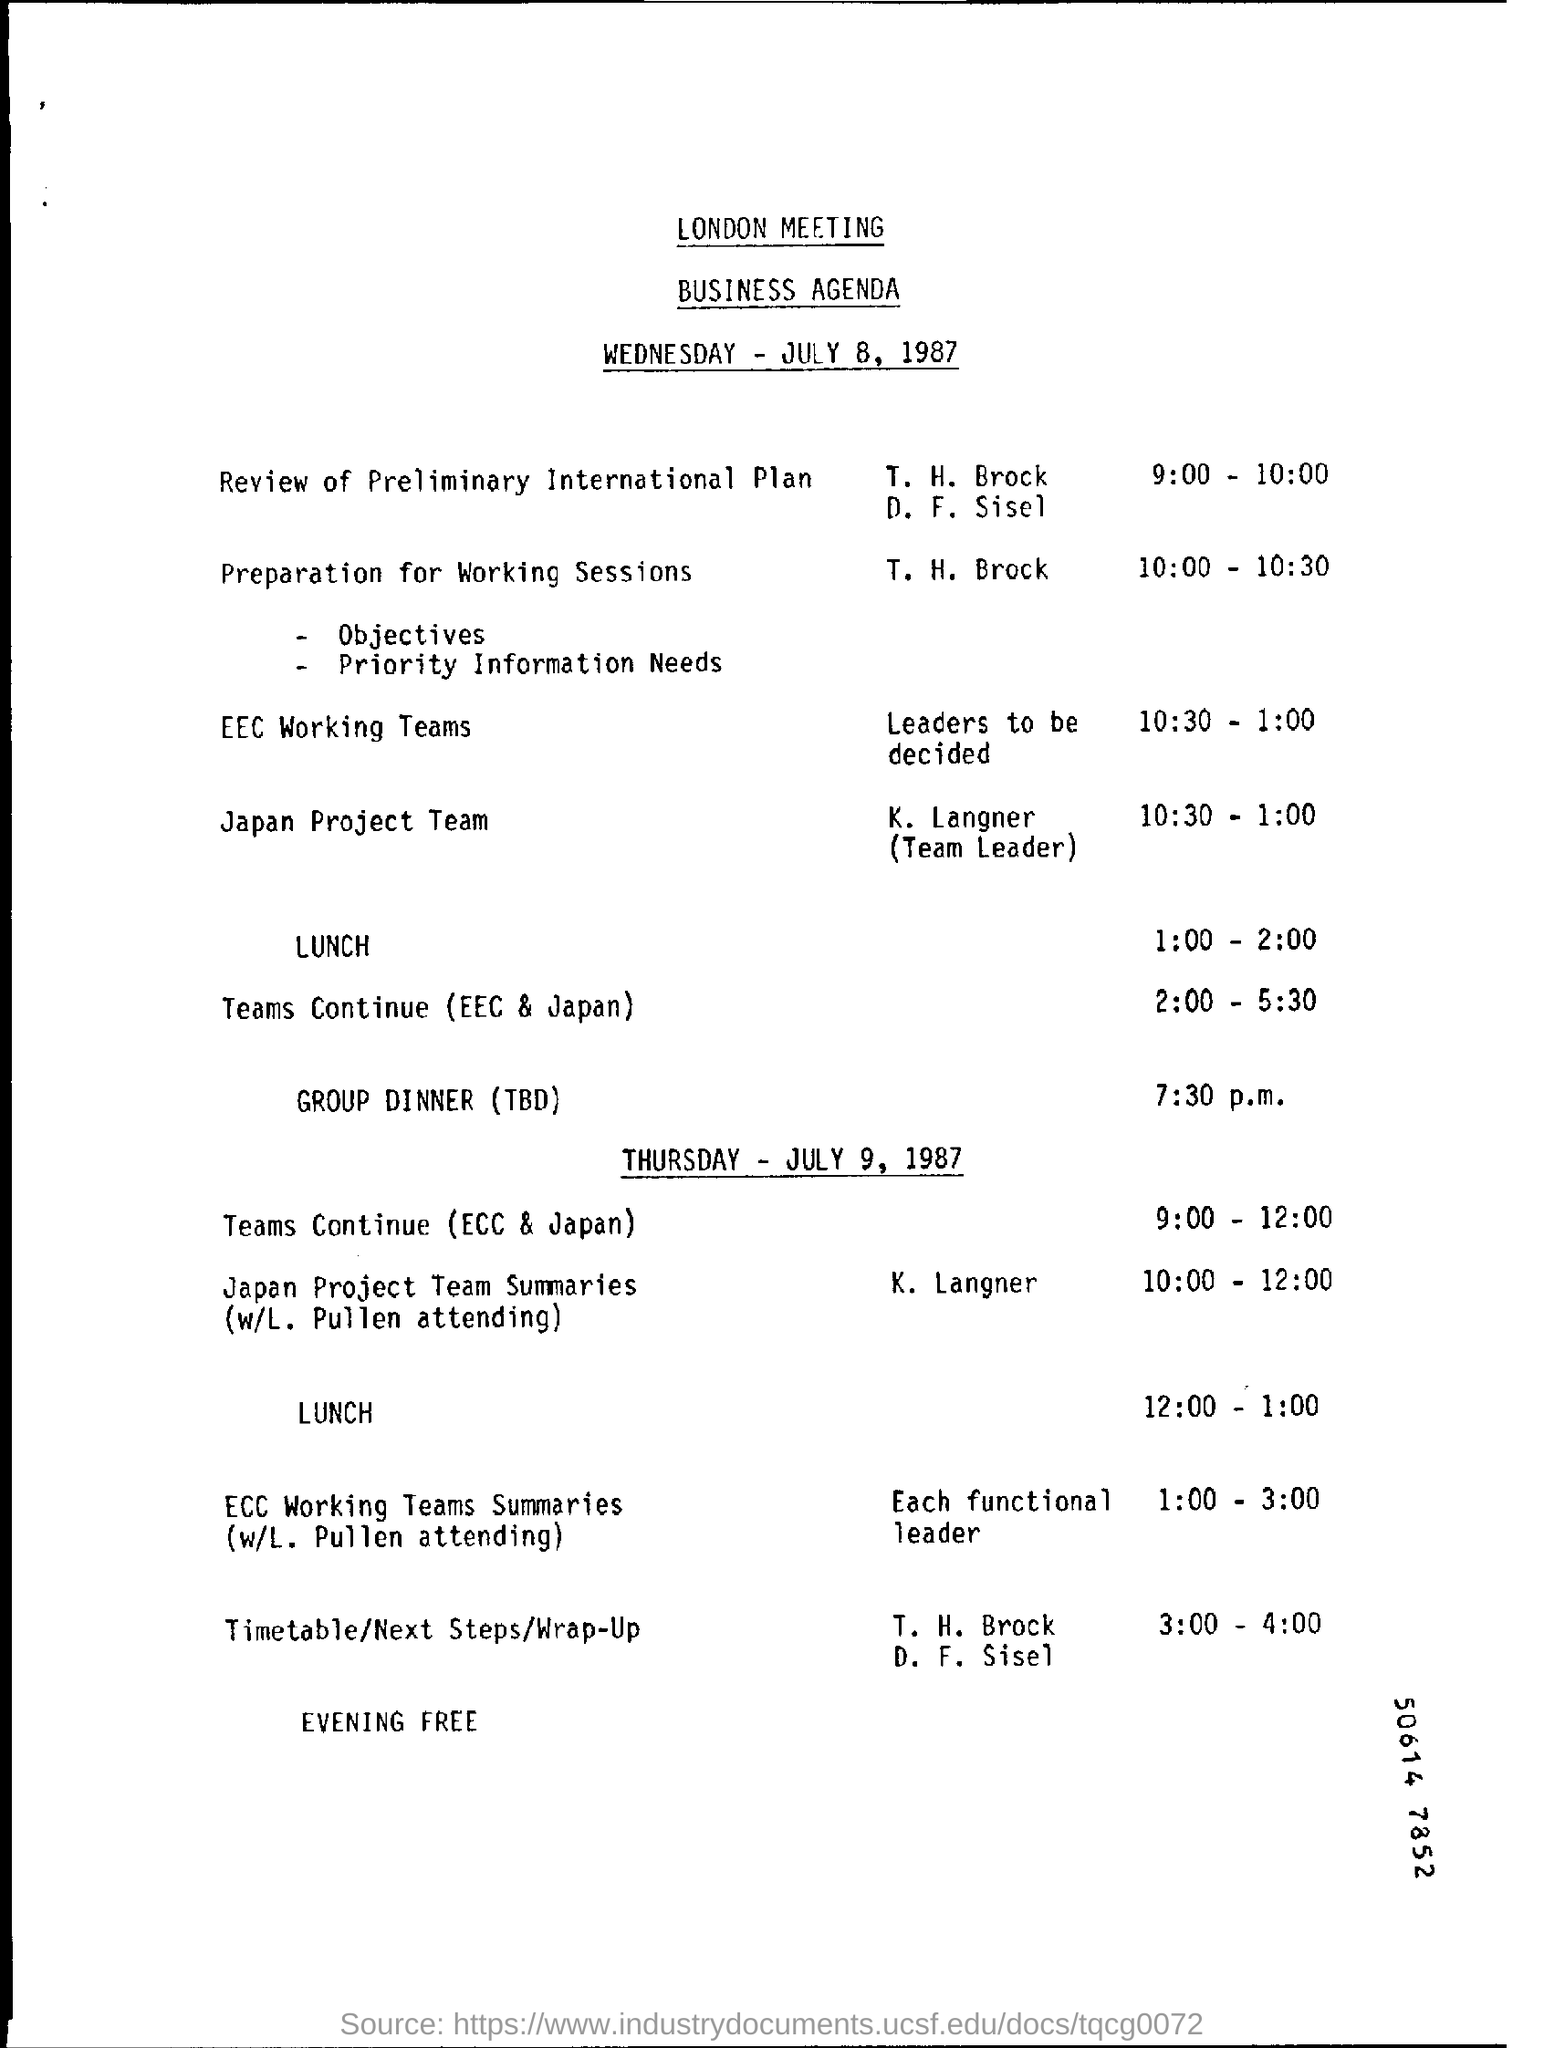Identify some key points in this picture. T. H. Brock will be responsible for the preparation for the Working Sessions. From 10:30 to 1:00, the event was the EEC Working Teams. 